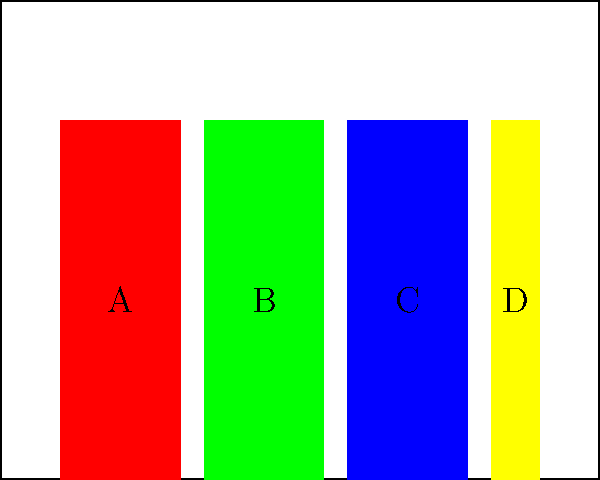As the manager of a large chain bookstore, you're arranging a display shelf for a literary event to compete with the independent bookstore down the street. The shelf contains four books of different colors and sizes, as shown in the diagram. How many distinct arrangements of these books are possible if you consider all symmetries of the bookshelf, including rotations and reflections? To solve this problem, we need to consider the symmetry group of the bookshelf arrangement:

1. First, let's count the total number of permutations without considering symmetries:
   There are 4 books, so there are 4! = 24 possible arrangements.

2. Now, let's consider the symmetries of the bookshelf:
   a) Rotation by 180 degrees (flipping the shelf upside down)
   b) Reflection (mirroring the shelf horizontally)

3. These symmetries form a group isomorphic to $C_2 \times C_2$, which has 4 elements:
   - Identity
   - Rotation by 180 degrees
   - Reflection
   - Rotation followed by reflection (or vice versa)

4. By Burnside's lemma, the number of distinct arrangements under these symmetries is:

   $$N = \frac{1}{|G|} \sum_{g \in G} |X^g|$$

   Where $|G|$ is the order of the symmetry group (4 in this case), and $|X^g|$ is the number of arrangements fixed by each symmetry.

5. Let's count the fixed arrangements for each symmetry:
   - Identity: All 24 arrangements are fixed
   - Rotation by 180 degrees: No arrangements are fixed (0)
   - Reflection: Arrangements with A-D and B-C swapped (6 arrangements)
   - Rotation followed by reflection: No arrangements are fixed (0)

6. Applying Burnside's lemma:

   $$N = \frac{1}{4} (24 + 0 + 6 + 0) = \frac{30}{4} = 7.5$$

7. Since we can't have fractional arrangements, we round down to 7.

Therefore, there are 7 distinct arrangements possible when considering all symmetries of the bookshelf.
Answer: 7 distinct arrangements 